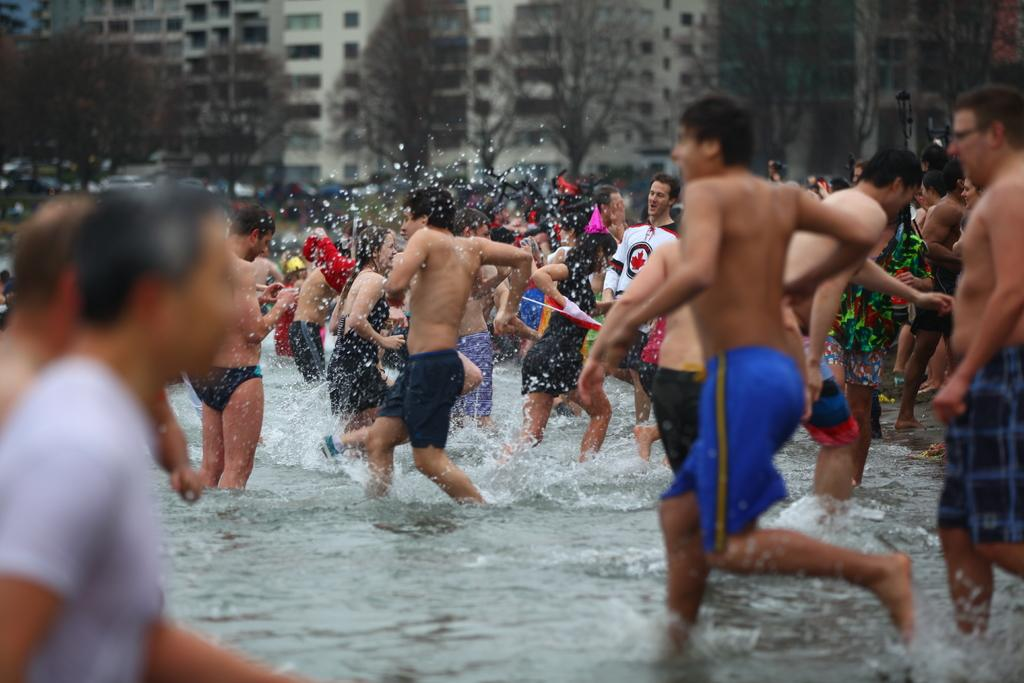What are the people in the image doing? There is a group of people in the water. What can be seen in the background of the image? There are trees visible in the image. What type of structures are present in the image? There are buildings in the image. What type of cub is visible in the image? There is no cub present in the image. How many pins are being used by the manager in the image? There is no manager or pins present in the image. 